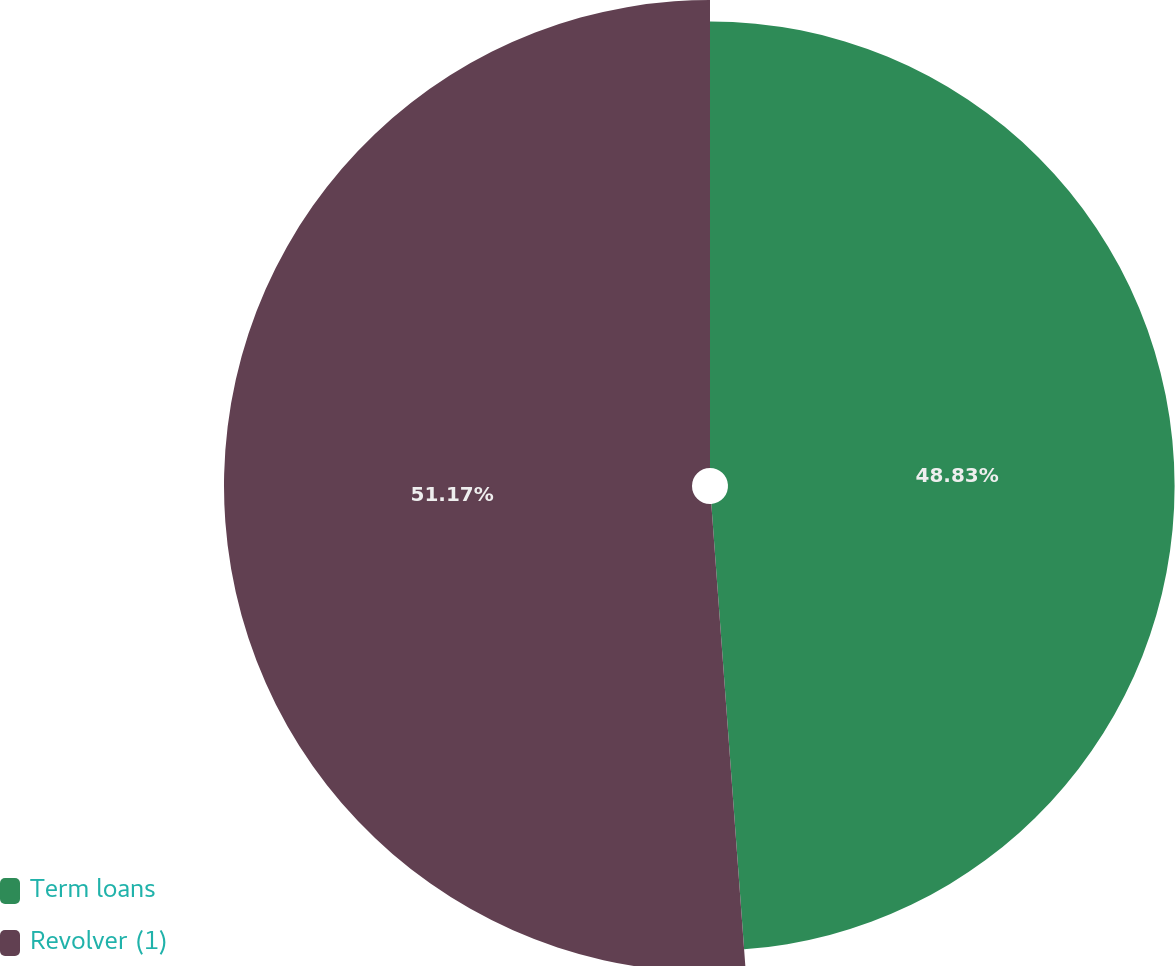<chart> <loc_0><loc_0><loc_500><loc_500><pie_chart><fcel>Term loans<fcel>Revolver (1)<nl><fcel>48.83%<fcel>51.17%<nl></chart> 